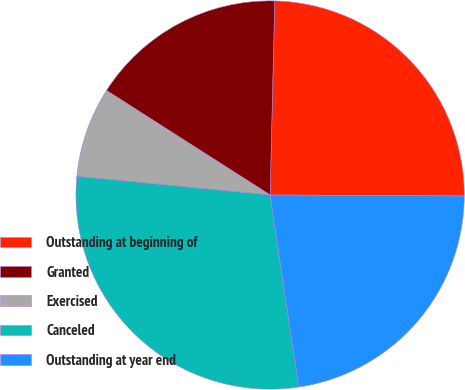Convert chart. <chart><loc_0><loc_0><loc_500><loc_500><pie_chart><fcel>Outstanding at beginning of<fcel>Granted<fcel>Exercised<fcel>Canceled<fcel>Outstanding at year end<nl><fcel>24.7%<fcel>16.33%<fcel>7.51%<fcel>28.9%<fcel>22.56%<nl></chart> 